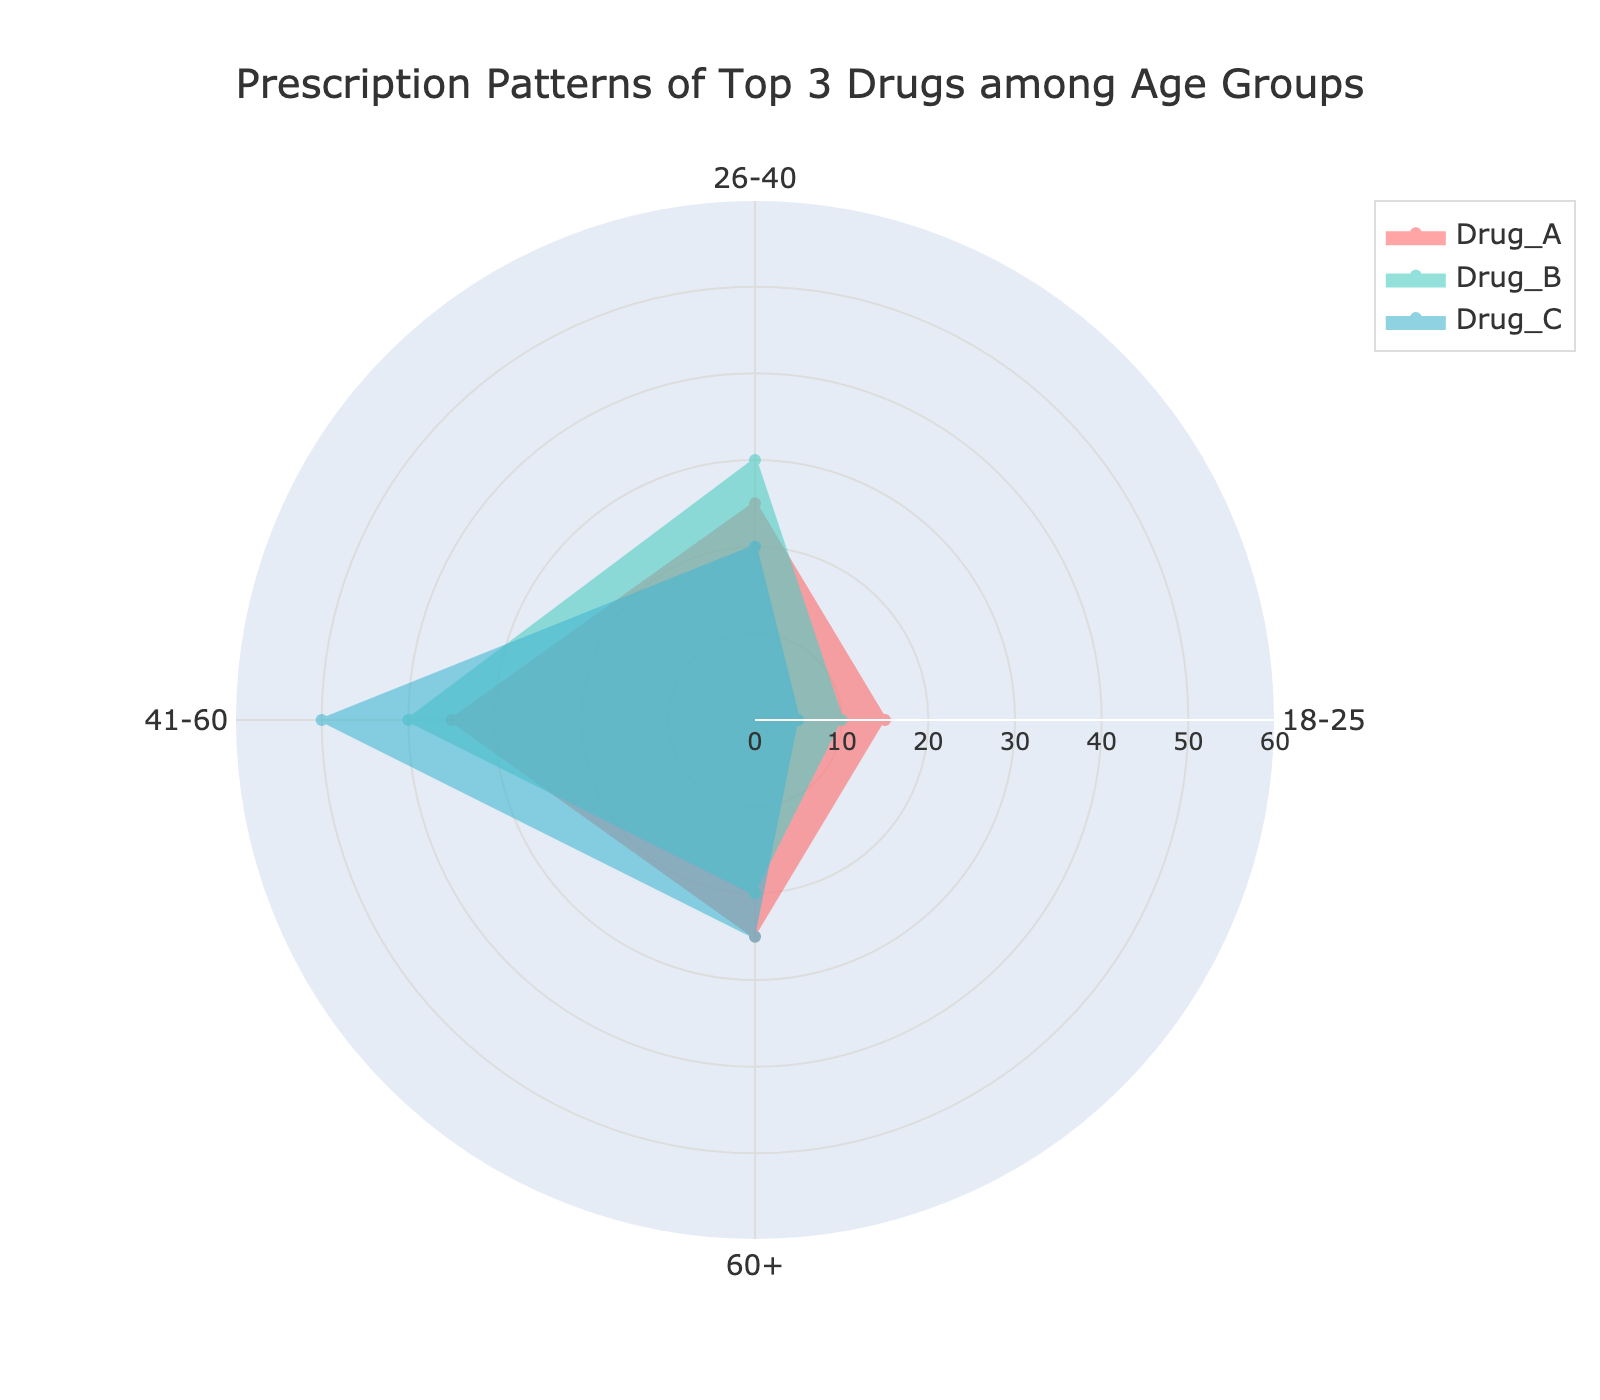What is the title of the figure? The title of the figure is typically located at the top of the chart and summarizes what the data represents. In this case, it states: "Prescription Patterns of Top 3 Drugs among Age Groups."
Answer: Prescription Patterns of Top 3 Drugs among Age Groups What percentage of Drug_A is prescribed in the 41-60 age group? To find this, look at the value for Drug_A in the segment corresponding to the 41-60 age group. The prescription percentage is indicated by the radial distance from the center. The data shows it is 35%.
Answer: 35% How does the percentage of prescriptions for Drug_B in the 60+ age group compare to Drug_C in the same age group? Drug_B's percentage in the 60+ age group is at a radial distance of 20%, whereas Drug_C's percentage in the same age group is at 25%. This is a straightforward comparison.
Answer: Drug_C is higher by 5% What is the average percentage of prescriptions for Drug_C across all age groups? To find the average, add the percentages for all the age groups for Drug_C: 5 (18-25) + 20 (26-40) + 50 (41-60) + 25 (60+), then divide the sum by the number of age groups, which is 4.
Answer: 25% In which age group does Drug_A have the highest prescription percentage? By visually inspecting the chart, the segment with the highest radial value for Drug_A can be seen. For Drug_A, this is the 41-60 age group with 35%.
Answer: 41-60 How much is the difference in prescriptions between Drug_A and Drug_B in the 26-40 age group? Drug_A has a prescription percentage of 25% in the 26-40 age group, and Drug_B has 30% in the same group. The difference between these two percentages can be calculated as 30% - 25%.
Answer: 5% Which drug has the lowest prescription percentage in the 18-25 age group? By looking at the chart for the 18-25 age group, Drug_C has the lowest radial distance, representing 5%.
Answer: Drug_C If you were to combine the percentages of all drugs in the 60+ age group, what would be the total percentage? Add the radial values for all three drugs in the 60+ age group: Drug_A (25%) + Drug_B (20%) + Drug_C (25%).
Answer: 70% Is there an age group where Drug_B has the highest prescription percentage compared to the other drugs? By observing the segments for Drug_B, the age group where Drug_B has the highest value is 41-60 with 40%, which is the highest for this drug across all groups.
Answer: 41-60 What is the range of prescription percentages for Drug_A across all age groups? The range is the difference between the maximum and minimum prescription percentages of Drug_A. The highest is 35% (41-60) and the lowest is 15% (18-25). The range is calculated as 35% - 15%.
Answer: 20% 